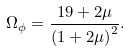Convert formula to latex. <formula><loc_0><loc_0><loc_500><loc_500>\Omega _ { \phi } = \frac { 1 9 + 2 \mu } { \left ( 1 + 2 \mu \right ) ^ { 2 } } .</formula> 